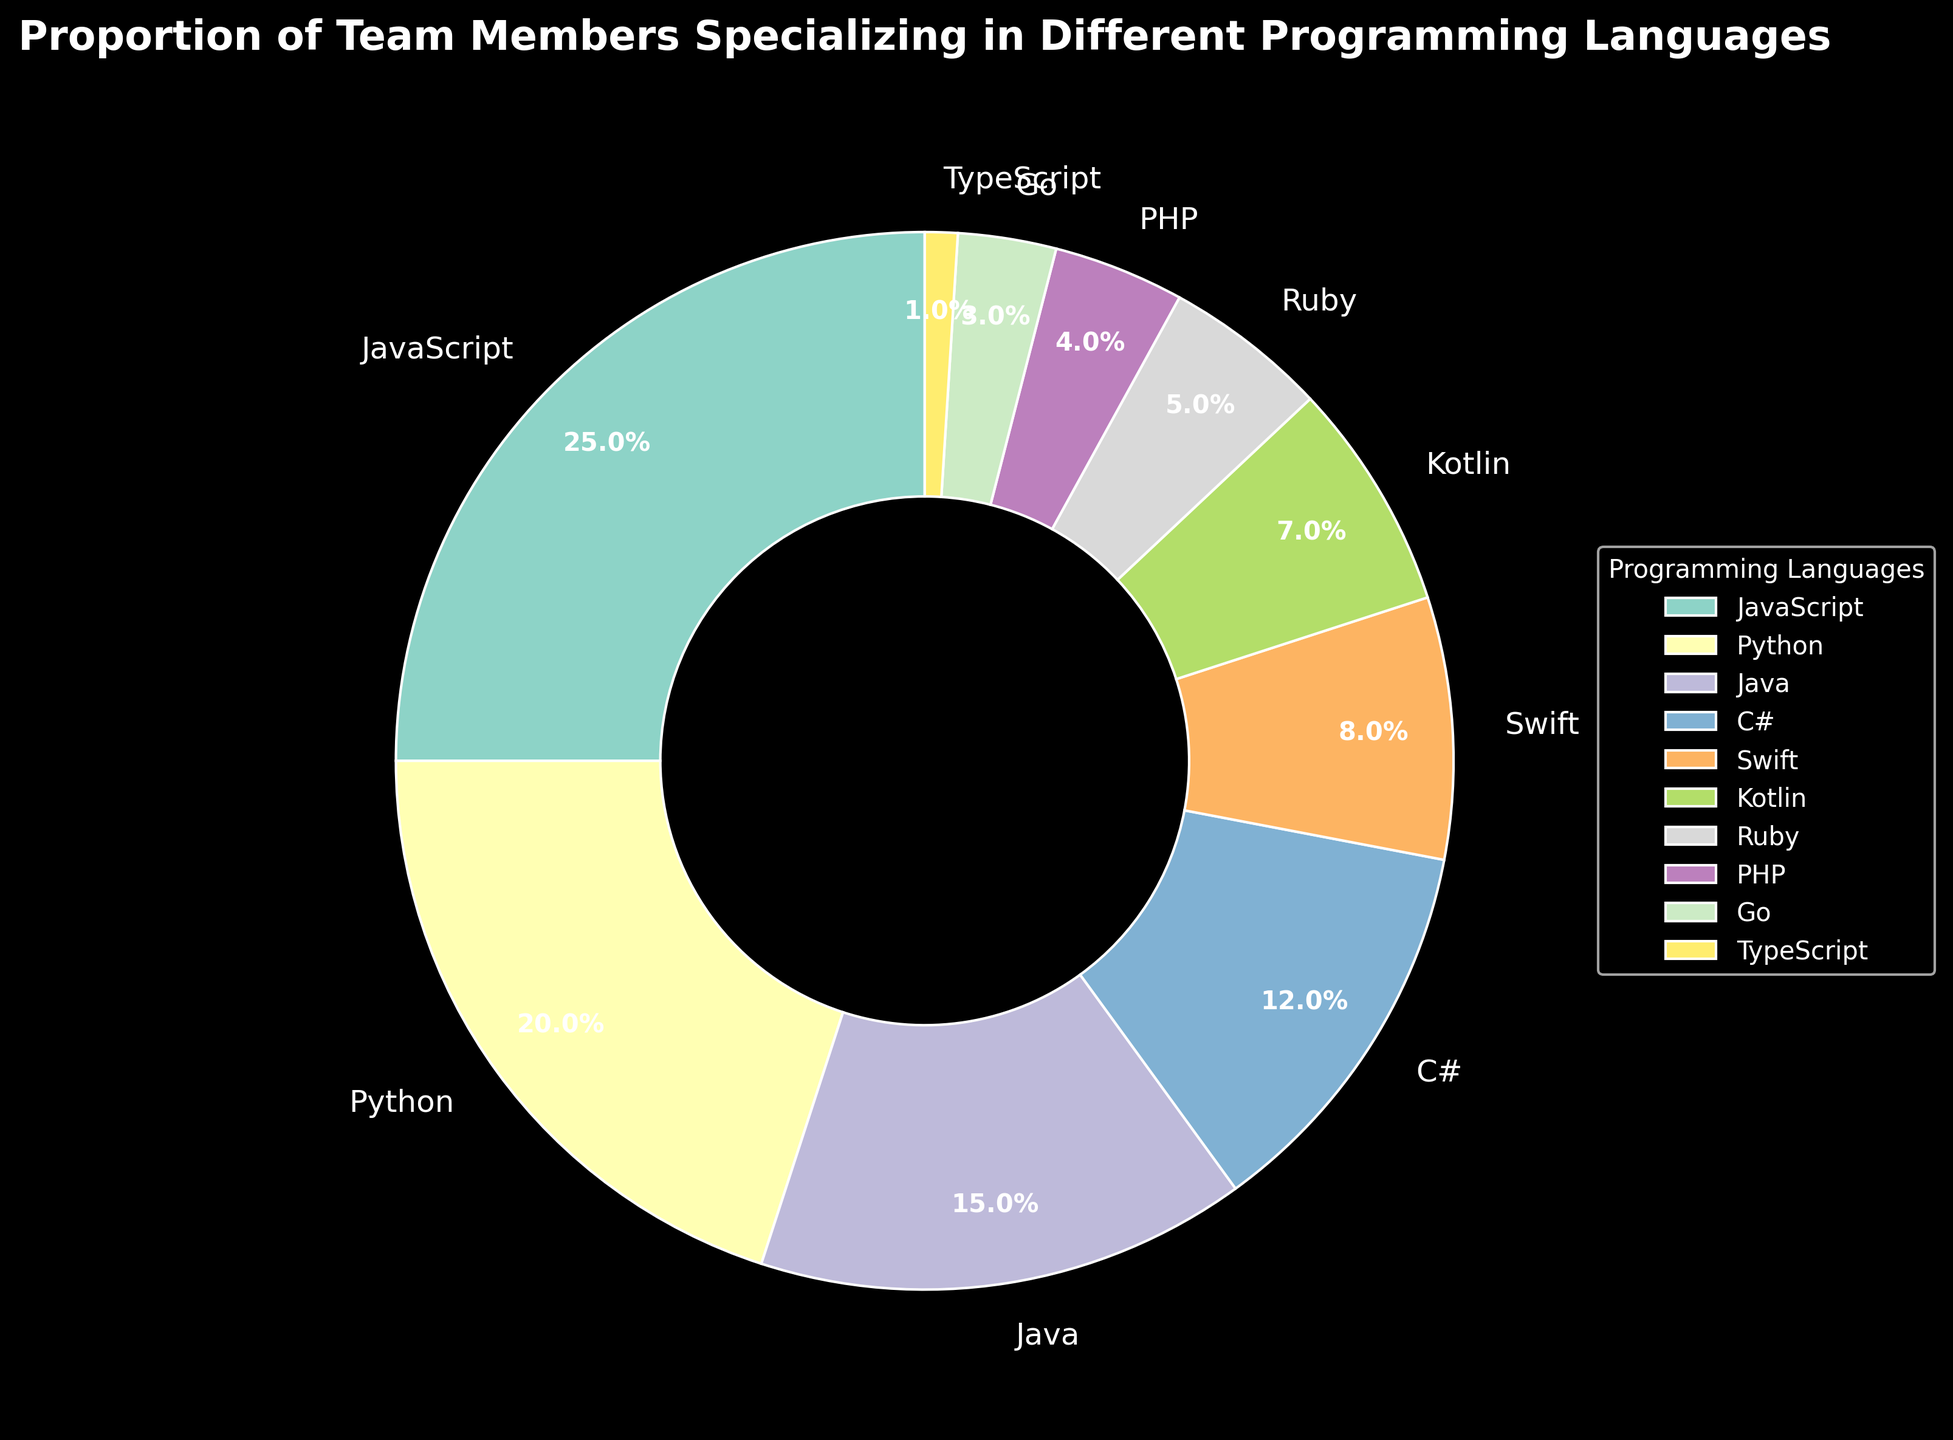What is the proportion of team members specializing in Python? Locate the 'Python' section in the pie chart and refer to its percentage label. Python is marked with 20%.
Answer: 20% Which programming language has the highest proportion of team members? Identify the largest wedge in the pie chart or the highest percentage label. JavaScript occupies the largest wedge at 25%.
Answer: JavaScript Compare the proportion of team members specializing in Java versus Swift. Which one is higher and by how much? Compare the percentage labels for Java and Swift. Java is at 15% and Swift is at 8%. The difference is 15% - 8% = 7%.
Answer: Java, by 7% What is the combined percentage of team members specializing in Kotlin and Ruby? Locate the percentages for Kotlin and Ruby, which are 7% and 5%, respectively. Add these together: 7% + 5% = 12%.
Answer: 12% Which programming language has the lowest proportion of team members? Identify the smallest wedge in the pie chart or the lowest percentage label. TypeScript holds the smallest wedge at 1%.
Answer: TypeScript How much larger is the proportion of team members specializing in JavaScript compared to PHP? Refer to the percentages for JavaScript and PHP, which are 25% and 4%, respectively. Subtract the smaller percentage from the larger one: 25% - 4% = 21%.
Answer: 21% What is the percentage of team members not specializing in the top 3 languages (JavaScript, Python, Java)? Calculate the sum of the top 3 percentages: JavaScript (25%) + Python (20%) + Java (15%) = 60%. Subtract this from 100%: 100% - 60% = 40%.
Answer: 40% Which has a higher percentage, C# or Swift, and by how much? Compare the percentages for C# and Swift. C# is at 12% and Swift is at 8%. The difference is 12% - 8% = 4%.
Answer: C#, by 4% Group the languages into those with percentages greater than 10% and those with percentages less than or equal to 10%. How many languages fall into each group? Separate the languages based on their percentages. Greater than 10%: JavaScript (25%), Python (20%), Java (15%), C# (12%). Less than or equal to 10%: Swift (8%), Kotlin (7%), Ruby (5%), PHP (4%), Go (3%), TypeScript (1%). Count them in each group: 4 languages > 10% and 6 languages ≤ 10%.
Answer: 4 greater than 10%, 6 less than or equal to 10% What percentage of team members specialize in either PHP or Go? Locate the percentages for PHP and Go, which are 4% and 3%, respectively. Add these together: 4% + 3% = 7%.
Answer: 7% 